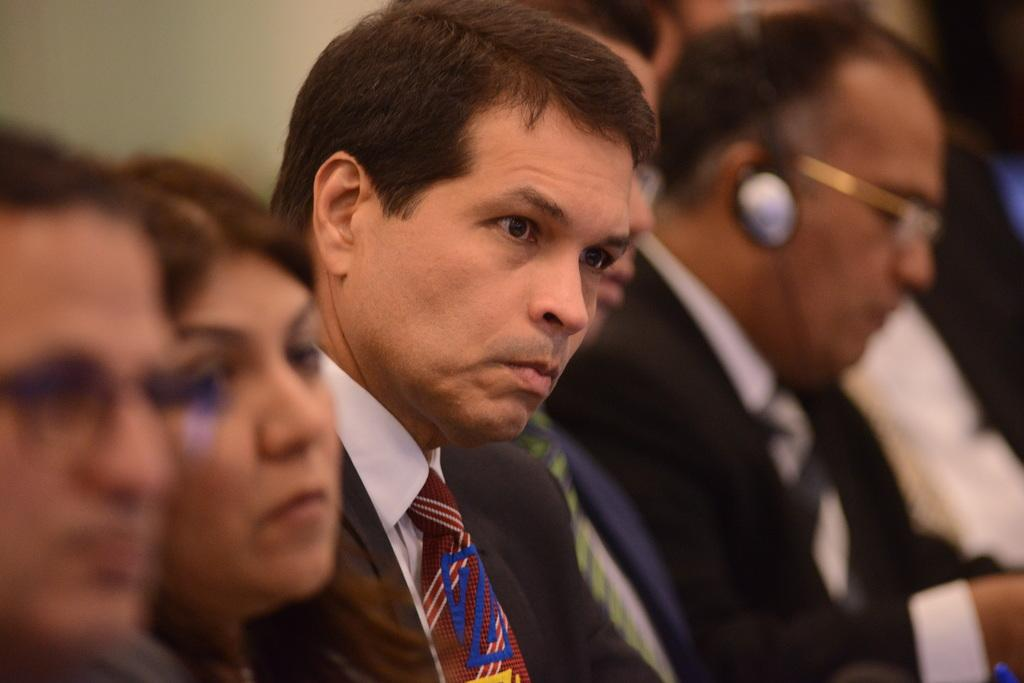Who or what can be seen in the image? There are people in the image. What are some of the people wearing? Some of the people are wearing suits. What else can be seen in the background of the image? There is a wall visible in the image. How many bananas can be seen on the wall in the image? There are no bananas present on the wall in the image. What attempt is being made by the people in the image? The image does not provide any information about an attempt being made by the people. 